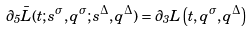<formula> <loc_0><loc_0><loc_500><loc_500>\partial _ { 5 } \bar { L } ( t ; s ^ { \sigma } , q ^ { \sigma } ; s ^ { \Delta } , q ^ { \Delta } ) = \partial _ { 3 } L \left ( t , q ^ { \sigma } , q ^ { \Delta } \right )</formula> 